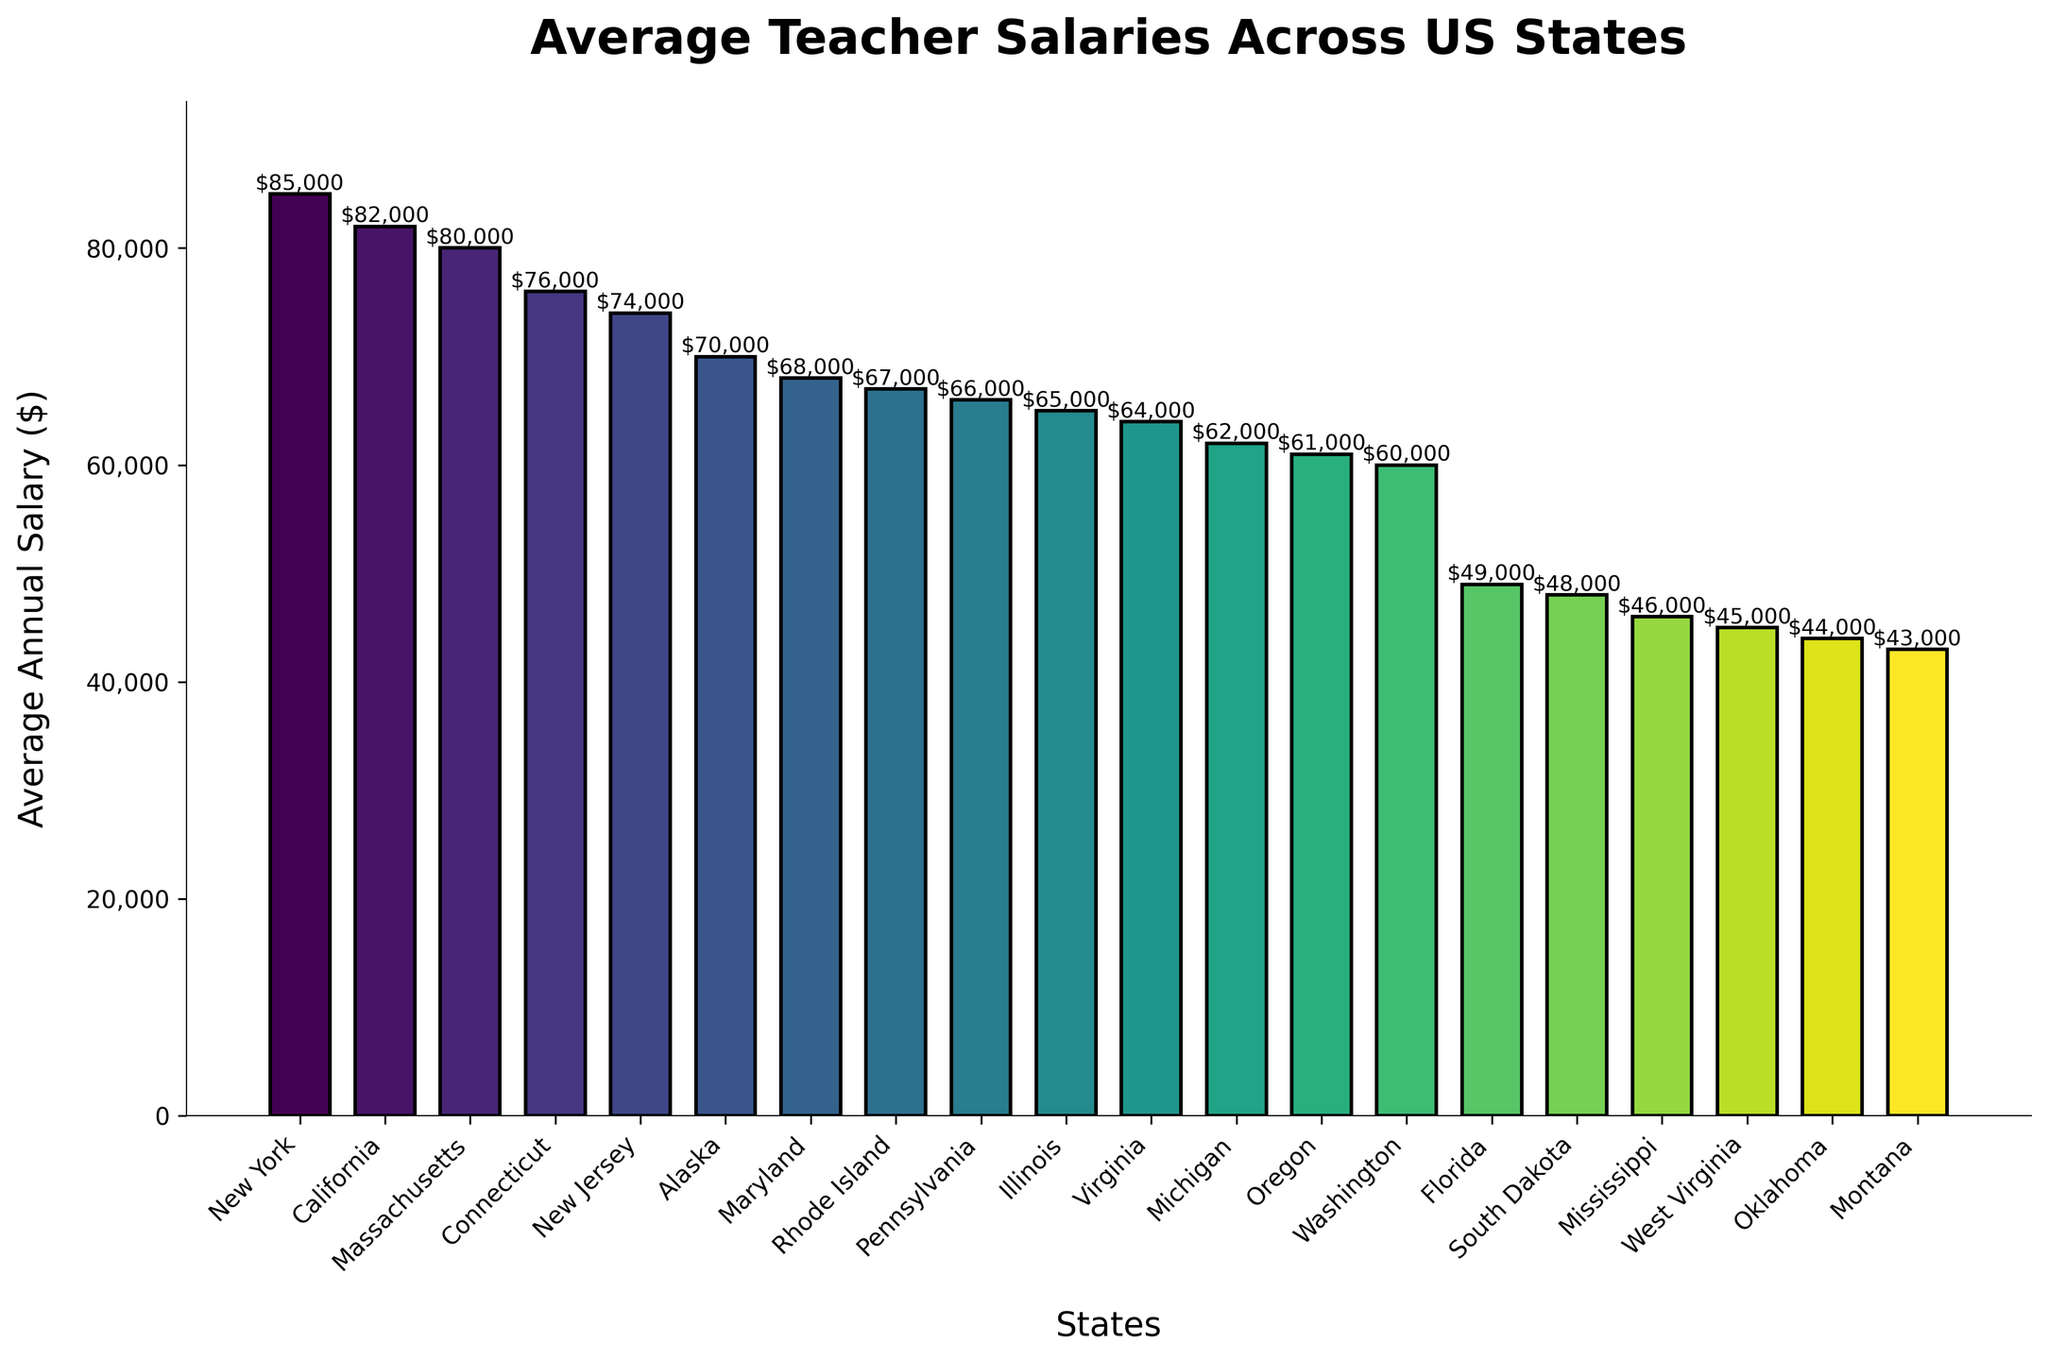Which state has the highest average teacher salary? The state with the highest bar in the chart represents the highest average teacher salary. In the chart, New York has the tallest bar.
Answer: New York Which state has the lowest average teacher salary? The state with the shortest bar in the chart represents the lowest average teacher salary. In the chart, Montana has the shortest bar.
Answer: Montana What is the average salary difference between teachers in California and Florida? To find the difference, subtract the average salary of teachers in Florida from the average salary of teachers in California. California's salary is $82,000 and Florida's salary is $49,000. Therefore, $82,000 - $49,000 = $33,000.
Answer: $33,000 Between Massachusetts and Connecticut, which state has a higher average teacher salary and by how much? Compare the height of the bars for Massachusetts and Connecticut. Massachusetts's bar is higher. To find the difference, subtract Connecticut's salary from Massachusetts's salary. Massachusetts's salary is $80,000 and Connecticut's salary is $76,000. Therefore, $80,000 - $76,000 = $4,000.
Answer: Massachusetts, $4,000 What is the combined average salary of teachers in New York and New Jersey? Add the average salaries of New York and New Jersey. New York's salary is $85,000 and New Jersey's salary is $74,000. Therefore, $85,000 + $74,000 = $159,000.
Answer: $159,000 How does the average teacher salary in Virginia compare to that in Michigan? Compare the heights of the bars for Virginia and Michigan. Virginia's salary is $64,000 and Michigan's salary is $62,000. Virginia's salary is higher.
Answer: Virginia is higher Which states have average teacher salaries above $70,000? Identify the bars that are above the $70,000 mark. The states are New York, California, Massachusetts, Connecticut, and New Jersey.
Answer: New York, California, Massachusetts, Connecticut, New Jersey How much more do teachers in Alaska make compared to those in Oklahoma? Subtract the average salary of teachers in Oklahoma from that of teachers in Alaska. Alaska's salary is $70,000 and Oklahoma's salary is $44,000. Therefore, $70,000 - $44,000 = $26,000.
Answer: $26,000 What is the range of average teacher salaries in this data set? The range is the difference between the highest and lowest values. The highest average salary is in New York ($85,000) and the lowest in Montana ($43,000). Therefore, $85,000 - $43,000 = $42,000.
Answer: $42,000 